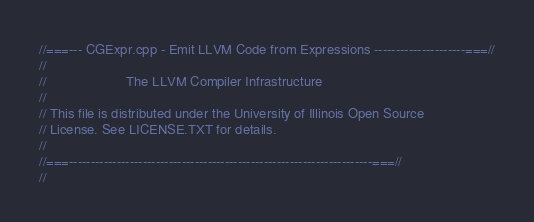Convert code to text. <code><loc_0><loc_0><loc_500><loc_500><_C++_>//===--- CGExpr.cpp - Emit LLVM Code from Expressions ---------------------===//
//
//                     The LLVM Compiler Infrastructure
//
// This file is distributed under the University of Illinois Open Source
// License. See LICENSE.TXT for details.
//
//===----------------------------------------------------------------------===//
//</code> 